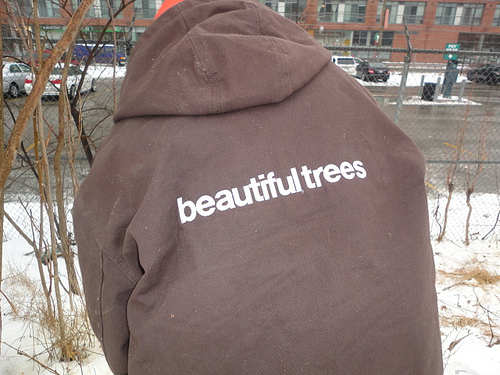<image>
Is the person on the snow? Yes. Looking at the image, I can see the person is positioned on top of the snow, with the snow providing support. 